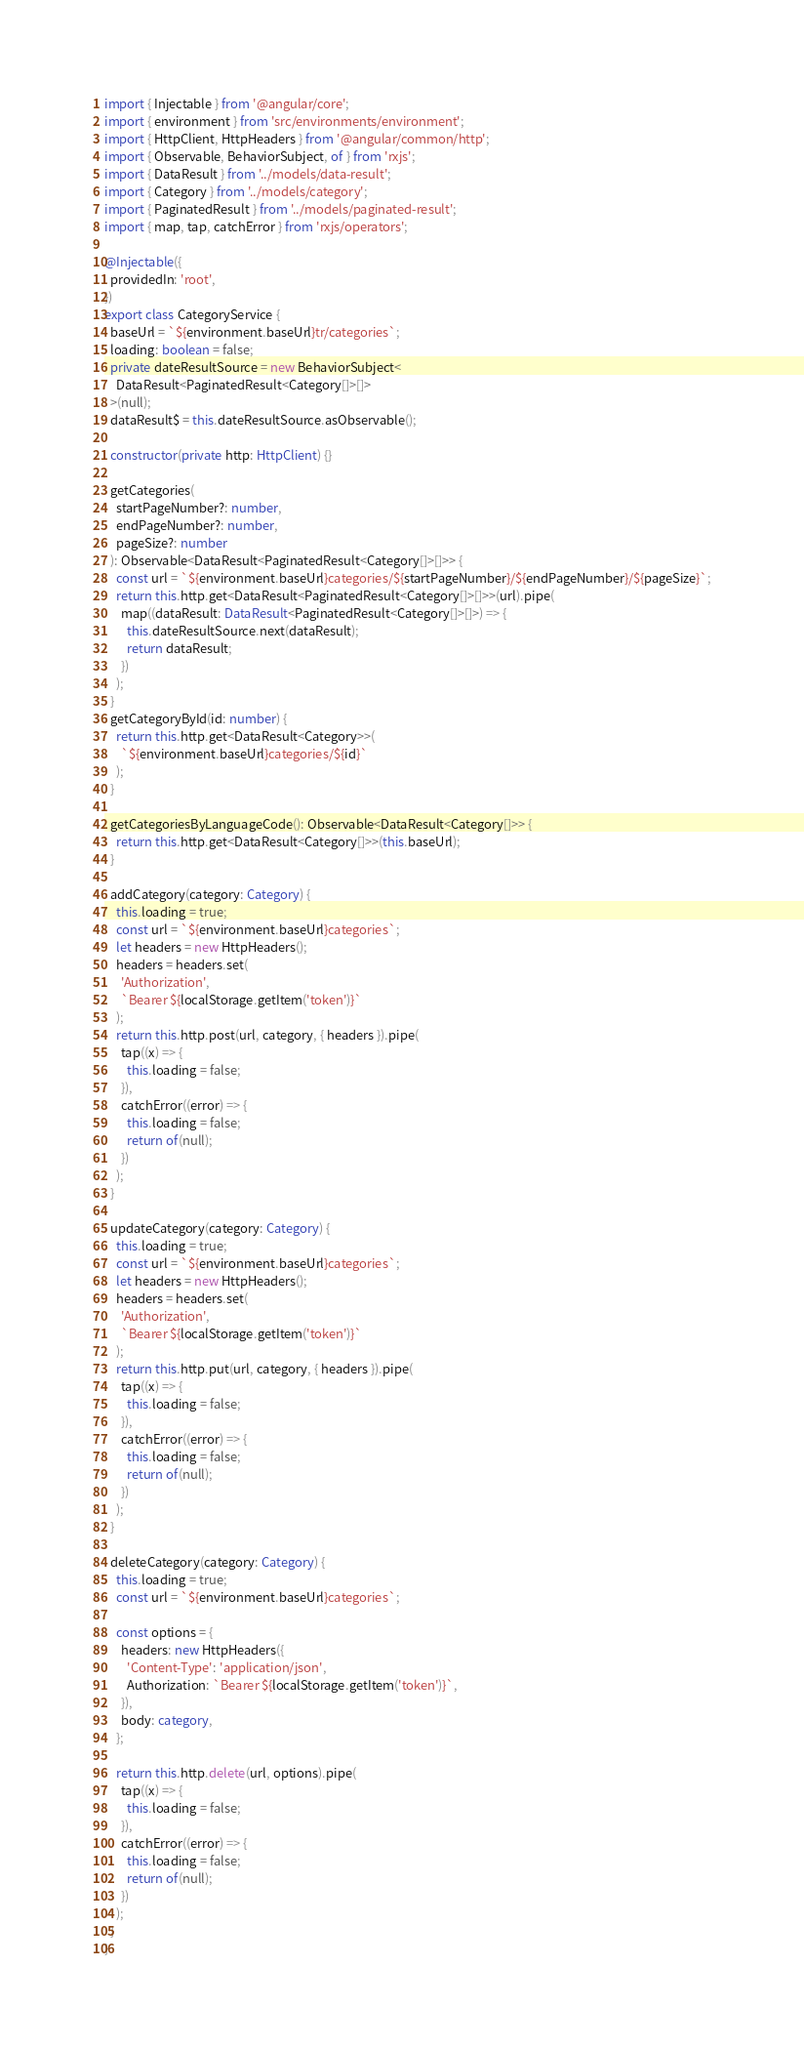<code> <loc_0><loc_0><loc_500><loc_500><_TypeScript_>import { Injectable } from '@angular/core';
import { environment } from 'src/environments/environment';
import { HttpClient, HttpHeaders } from '@angular/common/http';
import { Observable, BehaviorSubject, of } from 'rxjs';
import { DataResult } from '../models/data-result';
import { Category } from '../models/category';
import { PaginatedResult } from '../models/paginated-result';
import { map, tap, catchError } from 'rxjs/operators';

@Injectable({
  providedIn: 'root',
})
export class CategoryService {
  baseUrl = `${environment.baseUrl}tr/categories`;
  loading: boolean = false;
  private dateResultSource = new BehaviorSubject<
    DataResult<PaginatedResult<Category[]>[]>
  >(null);
  dataResult$ = this.dateResultSource.asObservable();

  constructor(private http: HttpClient) {}

  getCategories(
    startPageNumber?: number,
    endPageNumber?: number,
    pageSize?: number
  ): Observable<DataResult<PaginatedResult<Category[]>[]>> {
    const url = `${environment.baseUrl}categories/${startPageNumber}/${endPageNumber}/${pageSize}`;
    return this.http.get<DataResult<PaginatedResult<Category[]>[]>>(url).pipe(
      map((dataResult: DataResult<PaginatedResult<Category[]>[]>) => {
        this.dateResultSource.next(dataResult);
        return dataResult;
      })
    );
  }
  getCategoryById(id: number) {
    return this.http.get<DataResult<Category>>(
      `${environment.baseUrl}categories/${id}`
    );
  }

  getCategoriesByLanguageCode(): Observable<DataResult<Category[]>> {
    return this.http.get<DataResult<Category[]>>(this.baseUrl);
  }

  addCategory(category: Category) {
    this.loading = true;
    const url = `${environment.baseUrl}categories`;
    let headers = new HttpHeaders();
    headers = headers.set(
      'Authorization',
      `Bearer ${localStorage.getItem('token')}`
    );
    return this.http.post(url, category, { headers }).pipe(
      tap((x) => {
        this.loading = false;
      }),
      catchError((error) => {
        this.loading = false;
        return of(null);
      })
    );
  }

  updateCategory(category: Category) {
    this.loading = true;
    const url = `${environment.baseUrl}categories`;
    let headers = new HttpHeaders();
    headers = headers.set(
      'Authorization',
      `Bearer ${localStorage.getItem('token')}`
    );
    return this.http.put(url, category, { headers }).pipe(
      tap((x) => {
        this.loading = false;
      }),
      catchError((error) => {
        this.loading = false;
        return of(null);
      })
    );
  }

  deleteCategory(category: Category) {
    this.loading = true;
    const url = `${environment.baseUrl}categories`;

    const options = {
      headers: new HttpHeaders({
        'Content-Type': 'application/json',
        Authorization: `Bearer ${localStorage.getItem('token')}`,
      }),
      body: category,
    };

    return this.http.delete(url, options).pipe(
      tap((x) => {
        this.loading = false;
      }),
      catchError((error) => {
        this.loading = false;
        return of(null);
      })
    );
  }
}
</code> 